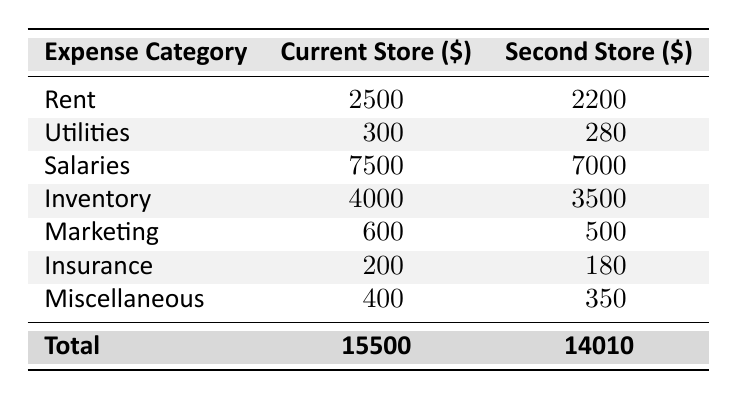What is the total monthly expense for the current store? Summing up all the monthly expenses for the current store: 2500 (Rent) + 300 (Utilities) + 7500 (Salaries) + 4000 (Inventory) + 600 (Marketing) + 200 (Insurance) + 400 (Miscellaneous) gives a total of 15500.
Answer: 15500 What is the rent for the second store? The rent for the second store is listed directly in the table as 2200.
Answer: 2200 Is the total monthly expense for the second store less than that of the current store? We can see the total for the second store is 14010 while the current store's total is 15500. Since 14010 is less than 15500, the statement is true.
Answer: Yes What is the difference in utility expenses between the two stores? The utility expense for the current store is 300, and for the second store, it's 280. To find the difference, subtract the second store's utilities from the current store's: 300 - 280 = 20.
Answer: 20 What are the salaries paid for each store combined? Adding the salaries for both stores provides: 7500 (current store) + 7000 (second store) = 14500.
Answer: 14500 What is the total amount spent on insurance for both stores? The insurance for the current store is 200, and for the second store, it's 180. Adding these gives: 200 + 180 = 380.
Answer: 380 Is the salary expense for the current store greater than the inventory expense for the second store? The salary expense for the current store is 7500 and the inventory expense for the second store is 3500. Since 7500 is greater than 3500, the statement is true.
Answer: Yes What is the average monthly expense for the current store? To find the average, sum up all the expenses (15500) and divide by the number of categories (7): 15500 / 7 = 2214.29.
Answer: 2214.29 Which store has higher miscellaneous expenses, and what is the difference? Current store has miscellaneous expenses of 400 and the second store has 350. The difference is calculated as 400 - 350 = 50, so the current store has higher miscellaneous expenses.
Answer: Current store, difference 50 